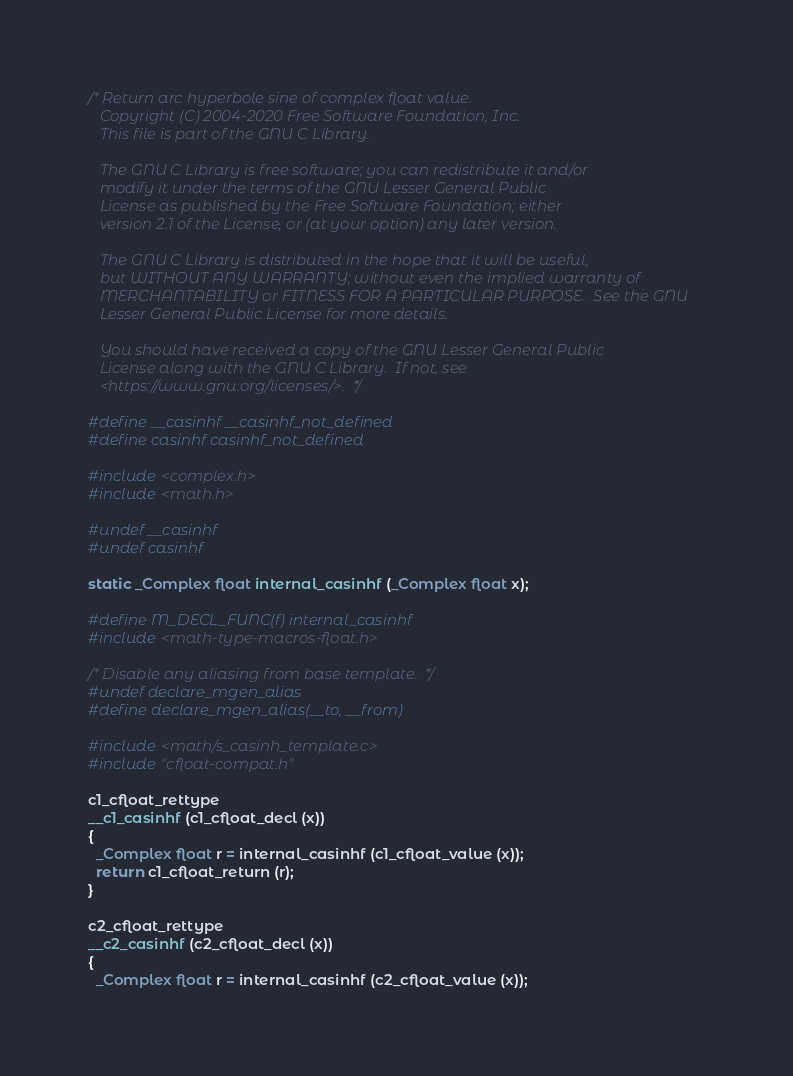<code> <loc_0><loc_0><loc_500><loc_500><_C_>/* Return arc hyperbole sine of complex float value.
   Copyright (C) 2004-2020 Free Software Foundation, Inc.
   This file is part of the GNU C Library.

   The GNU C Library is free software; you can redistribute it and/or
   modify it under the terms of the GNU Lesser General Public
   License as published by the Free Software Foundation; either
   version 2.1 of the License, or (at your option) any later version.

   The GNU C Library is distributed in the hope that it will be useful,
   but WITHOUT ANY WARRANTY; without even the implied warranty of
   MERCHANTABILITY or FITNESS FOR A PARTICULAR PURPOSE.  See the GNU
   Lesser General Public License for more details.

   You should have received a copy of the GNU Lesser General Public
   License along with the GNU C Library.  If not, see
   <https://www.gnu.org/licenses/>.  */

#define __casinhf __casinhf_not_defined
#define casinhf casinhf_not_defined

#include <complex.h>
#include <math.h>

#undef __casinhf
#undef casinhf

static _Complex float internal_casinhf (_Complex float x);

#define M_DECL_FUNC(f) internal_casinhf
#include <math-type-macros-float.h>

/* Disable any aliasing from base template.  */
#undef declare_mgen_alias
#define declare_mgen_alias(__to, __from)

#include <math/s_casinh_template.c>
#include "cfloat-compat.h"

c1_cfloat_rettype
__c1_casinhf (c1_cfloat_decl (x))
{
  _Complex float r = internal_casinhf (c1_cfloat_value (x));
  return c1_cfloat_return (r);
}

c2_cfloat_rettype
__c2_casinhf (c2_cfloat_decl (x))
{
  _Complex float r = internal_casinhf (c2_cfloat_value (x));</code> 